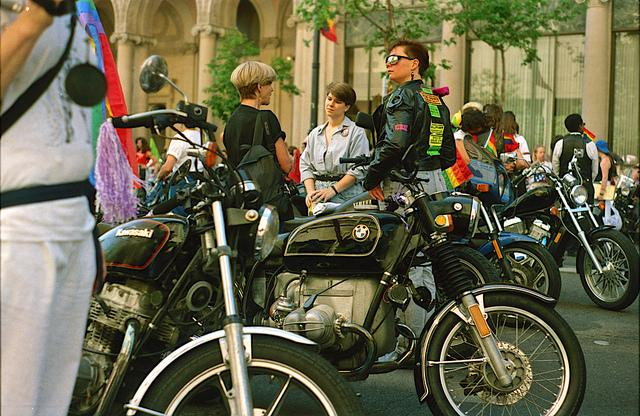What type of biking event is being held here? Please explain your reasoning. gay. The event is for gay pride. 